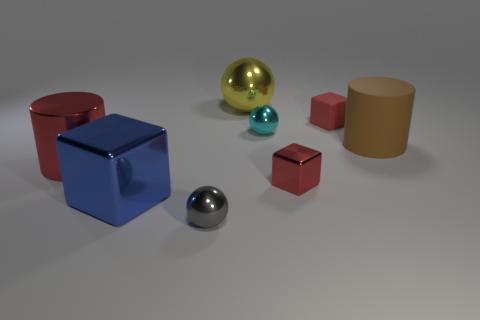Are there any big yellow balls that are in front of the metal block left of the tiny thing that is in front of the blue metallic thing? There are no big yellow balls in front of any objects. There is, however, one large yellow ball that appears to be behind the blue metallic cube if viewed from the camera's perspective. 